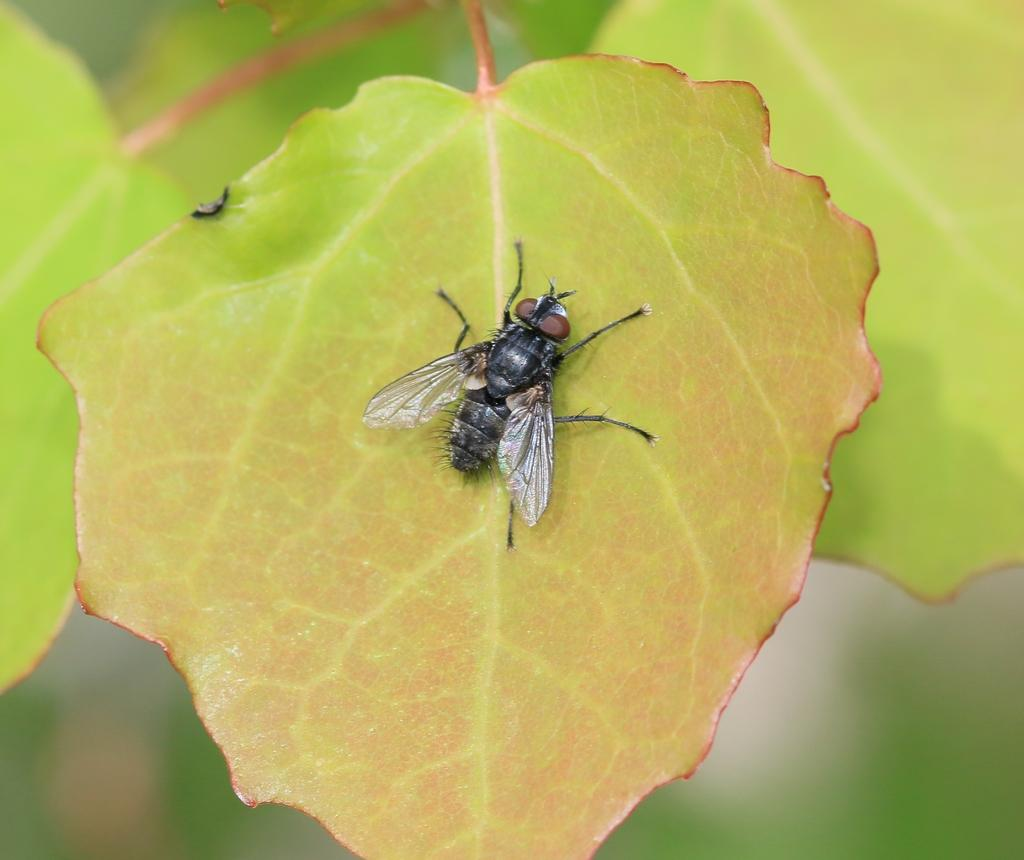What insect is present in the picture? There is a house fly in the picture. Where is the house fly located? The house fly is on a leaf. What else can be seen in the picture besides the house fly? There are other leaves visible in the picture. How many bikes are parked near the plantation in the image? There is no plantation or bikes present in the image; it features a house fly on a leaf. 